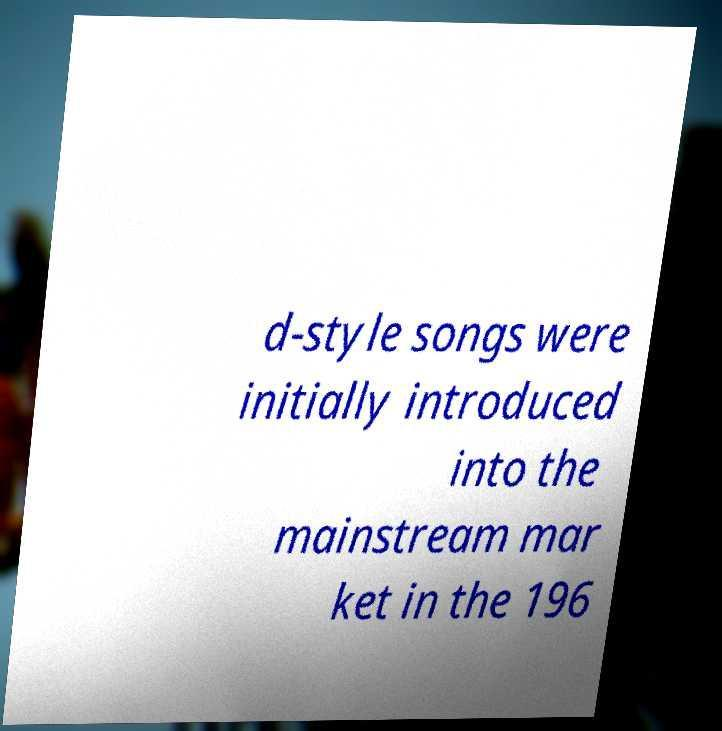Please read and relay the text visible in this image. What does it say? d-style songs were initially introduced into the mainstream mar ket in the 196 